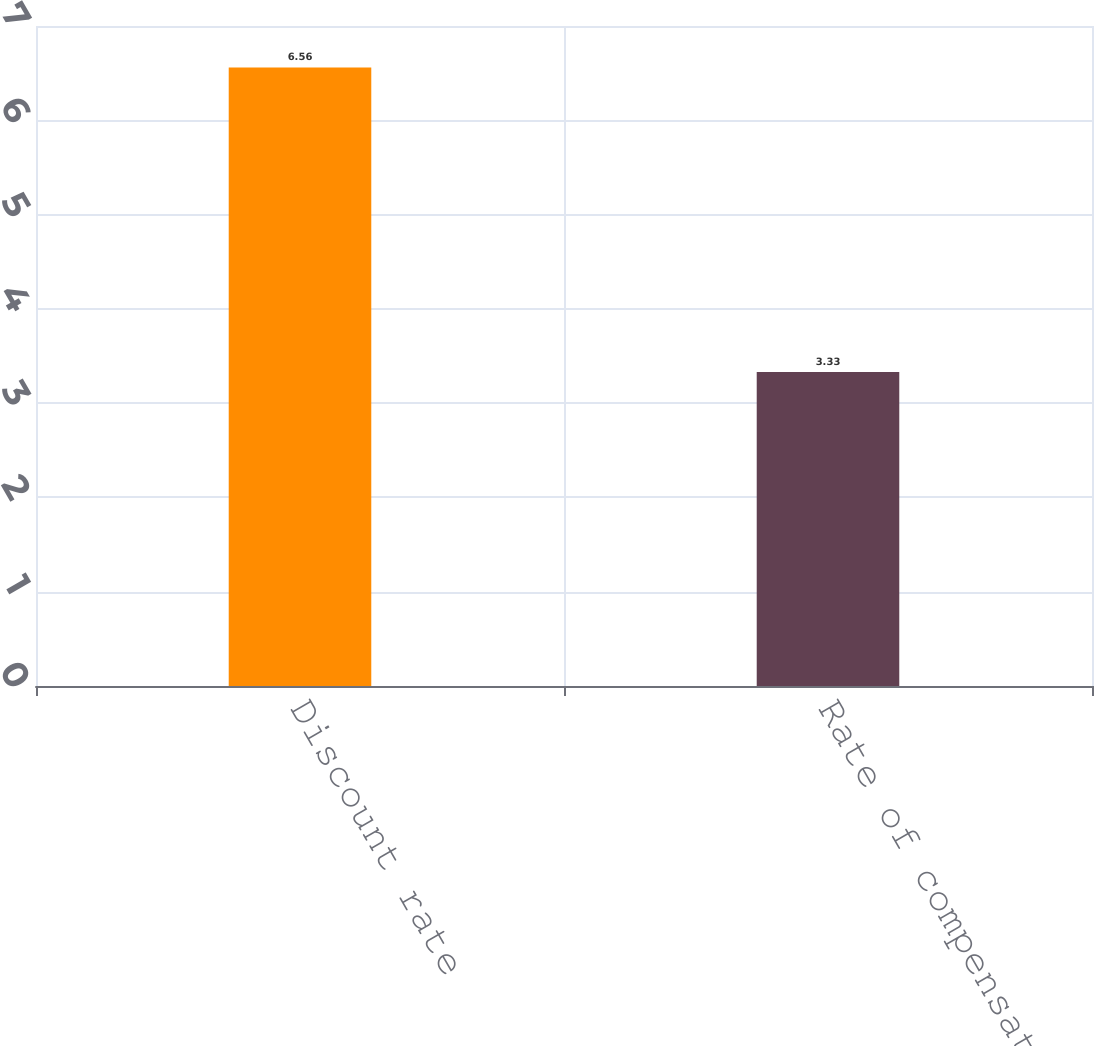Convert chart. <chart><loc_0><loc_0><loc_500><loc_500><bar_chart><fcel>Discount rate<fcel>Rate of compensation increase<nl><fcel>6.56<fcel>3.33<nl></chart> 